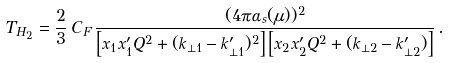<formula> <loc_0><loc_0><loc_500><loc_500>T _ { H _ { 2 } } = \frac { 2 } { 3 } \, C _ { F } \, \frac { ( 4 \pi \alpha _ { s } ( \mu ) ) ^ { 2 } } { \left [ x _ { 1 } x _ { 1 } ^ { \prime } Q ^ { 2 } + ( { k } _ { \perp 1 } - { k } _ { \perp 1 } ^ { \prime } ) ^ { 2 } \right ] \left [ x _ { 2 } x _ { 2 } ^ { \prime } Q ^ { 2 } + ( { k } _ { \perp 2 } - { k } _ { \perp 2 } ^ { \prime } ) \right ] } \, .</formula> 